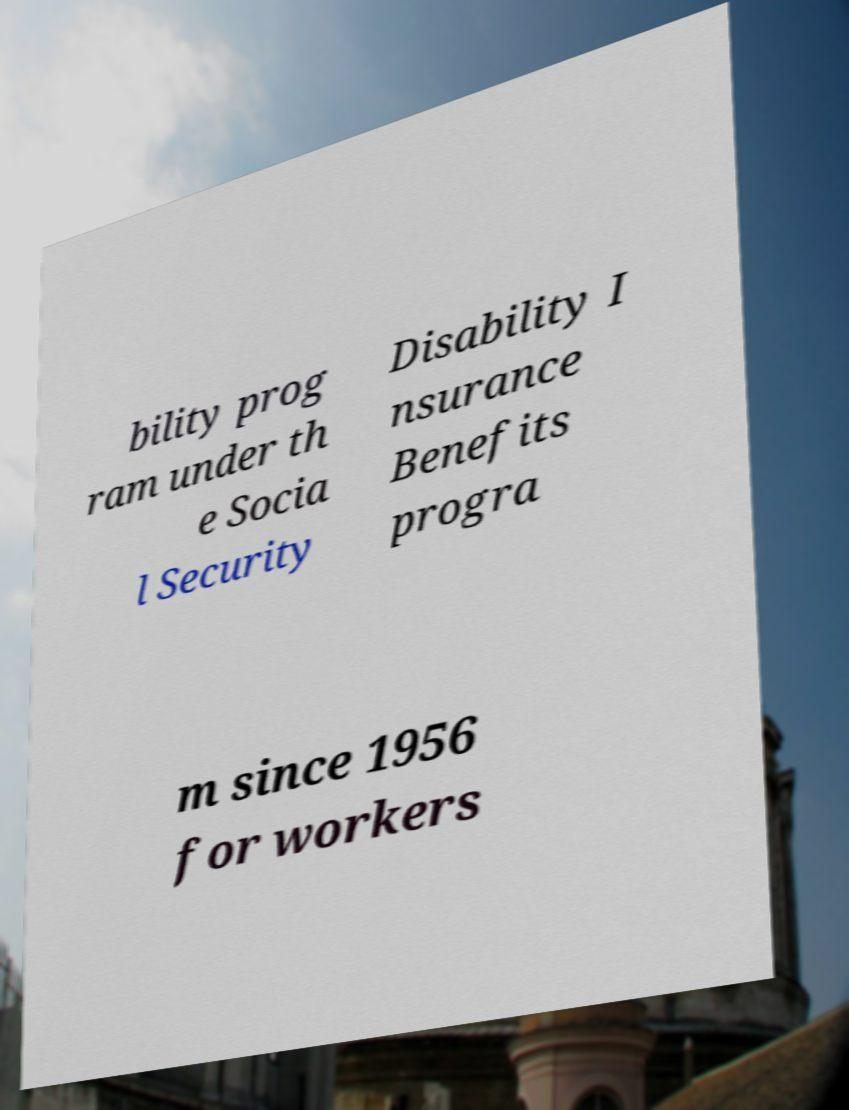There's text embedded in this image that I need extracted. Can you transcribe it verbatim? bility prog ram under th e Socia l Security Disability I nsurance Benefits progra m since 1956 for workers 